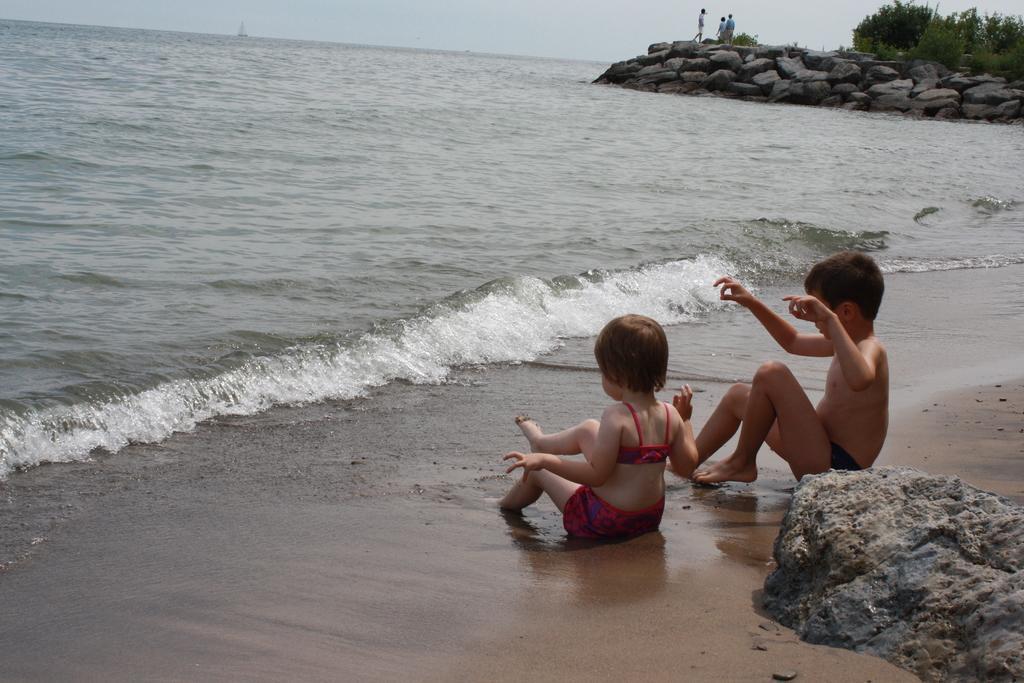Can you describe this image briefly? In this image we can see a boy and girl are sitting on sand at the water and behind them there is a stone. In the background there is an object on water, few persons standing on the stones, plants and sky. 